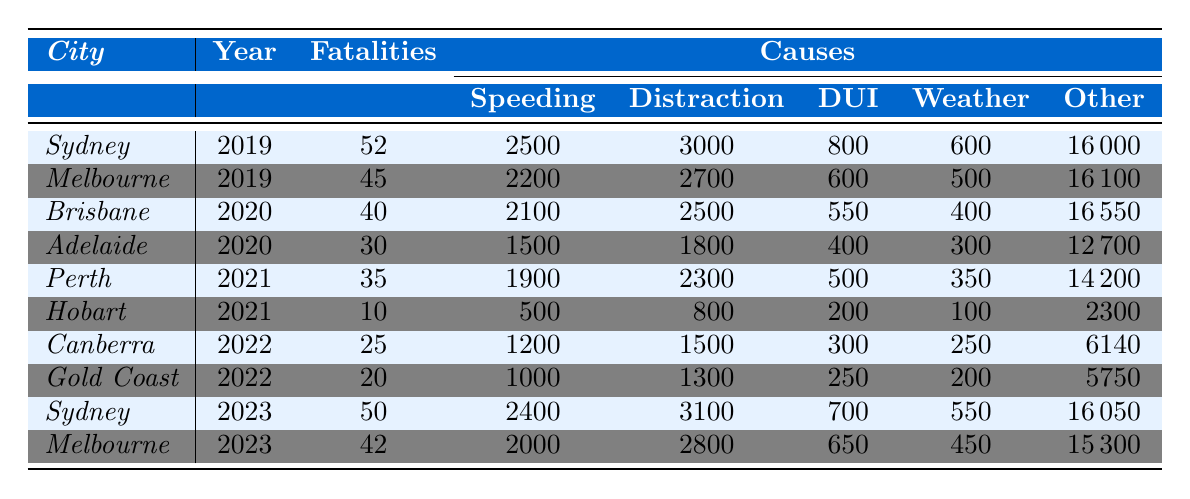What was the total number of traffic accidents in Brisbane in 2020? The table shows that Brisbane had a total of 12,500 accidents in 2020.
Answer: 12500 Which city had the highest number of fatalities in 2019? The table indicates that Sydney had 52 fatalities in 2019, which is higher than Melbourne's 45 fatalities.
Answer: Sydney What percentage of total accidents in Sydney in 2023 were due to speeding? In 2023, Sydney had 14,000 total accidents and 2,400 were due to speeding. To find the percentage, divide 2,400 by 14,000 and multiply by 100: (2400 / 14000) * 100 = 17.14%.
Answer: 17.14% What is the average number of fatalities across all cities for the year 2022? The fatalities for 2022 are 25 for Canberra and 20 for the Gold Coast, totaling 45. With two cities, the average is 45 / 2 = 22.5.
Answer: 22.5 How many accidents were attributed to distractions in Melbourne in 2023? The table presents that the number of distraction-caused accidents in Melbourne in 2023 was 2,800.
Answer: 2800 If we compare the total number of accidents from 2019 to 2023 in Sydney, was there an increase or decrease? In 2019, Sydney had 15,000 accidents, while in 2023 it had 14,000. This indicates a decrease of 1,000 accidents.
Answer: Decrease What is the total number of speeding-related accidents reported across all cities in 2021? Summing the speeding data from Perth (1,900) and Hobart (500) gives: 1,900 + 500 = 2,400 total speeding-related accidents in 2021.
Answer: 2400 Did any city report more than 50 fatalities in the year 2022? No city data in 2022 shows fatalities exceeding 50, the highest reported was 25 in Canberra.
Answer: No Which city's number of "other" accidents showed the greatest increase from 2021 to 2023? Sydney’s "other" accidents in 2021 was 14,200 and in 2023 it was 16,050. The increase is 16,050 - 14,200 = 1,850. No other city's data shows a larger increase.
Answer: Sydney Calculate the difference in total accidents from 2020 to 2022 for Adelaide. In 2020, Adelaide had 9,000 accidents, and in 2022 it had none reported. The difference is 9,000 - 8,000 = 1,000.
Answer: 1,000 